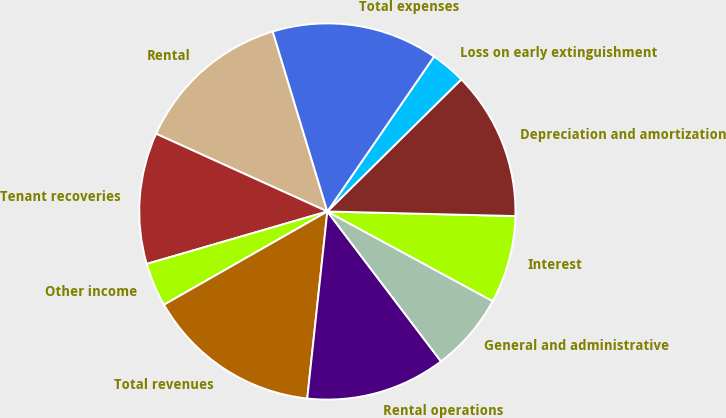<chart> <loc_0><loc_0><loc_500><loc_500><pie_chart><fcel>Rental<fcel>Tenant recoveries<fcel>Other income<fcel>Total revenues<fcel>Rental operations<fcel>General and administrative<fcel>Interest<fcel>Depreciation and amortization<fcel>Loss on early extinguishment<fcel>Total expenses<nl><fcel>13.53%<fcel>11.28%<fcel>3.76%<fcel>15.04%<fcel>12.03%<fcel>6.77%<fcel>7.52%<fcel>12.78%<fcel>3.01%<fcel>14.29%<nl></chart> 